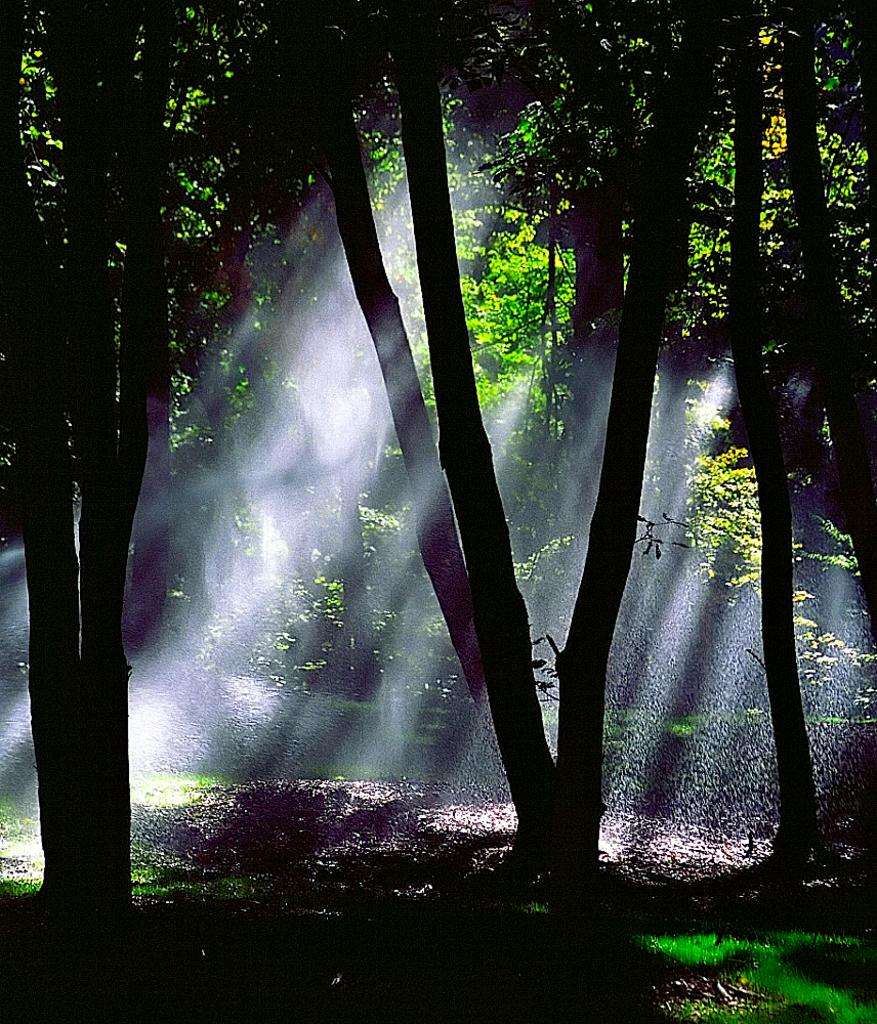What type of vegetation can be seen in the image? There are trees in the image. How is the sunlight affecting the ground in the image? Sunlight is falling on the ground between the trees. What type of soap is being used to clean the fan in the image? There is no fan or soap present in the image; it only features trees and sunlight falling on the ground. 